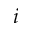<formula> <loc_0><loc_0><loc_500><loc_500>i</formula> 